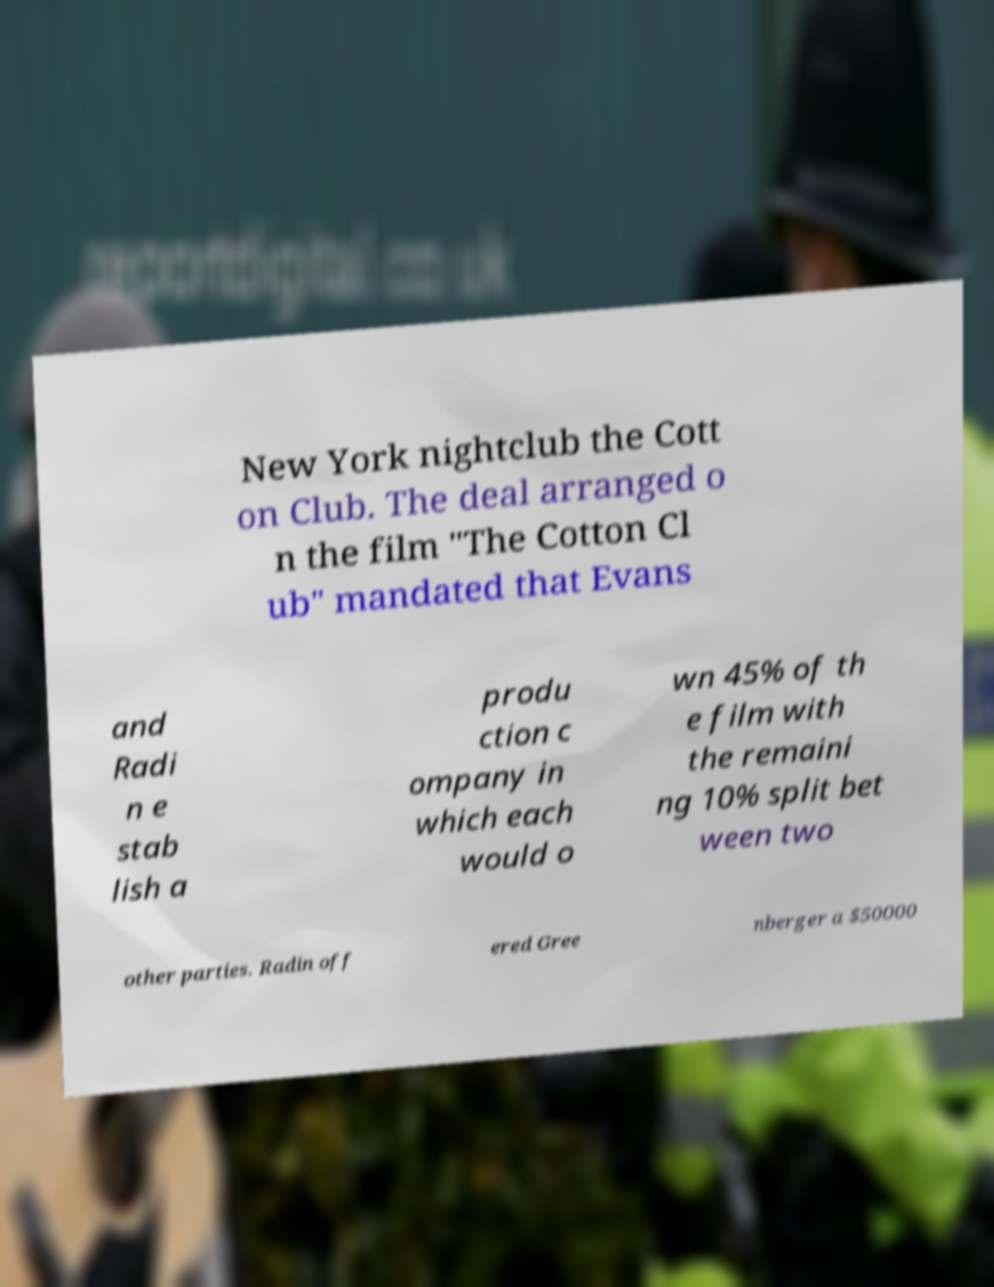What messages or text are displayed in this image? I need them in a readable, typed format. New York nightclub the Cott on Club. The deal arranged o n the film "The Cotton Cl ub" mandated that Evans and Radi n e stab lish a produ ction c ompany in which each would o wn 45% of th e film with the remaini ng 10% split bet ween two other parties. Radin off ered Gree nberger a $50000 